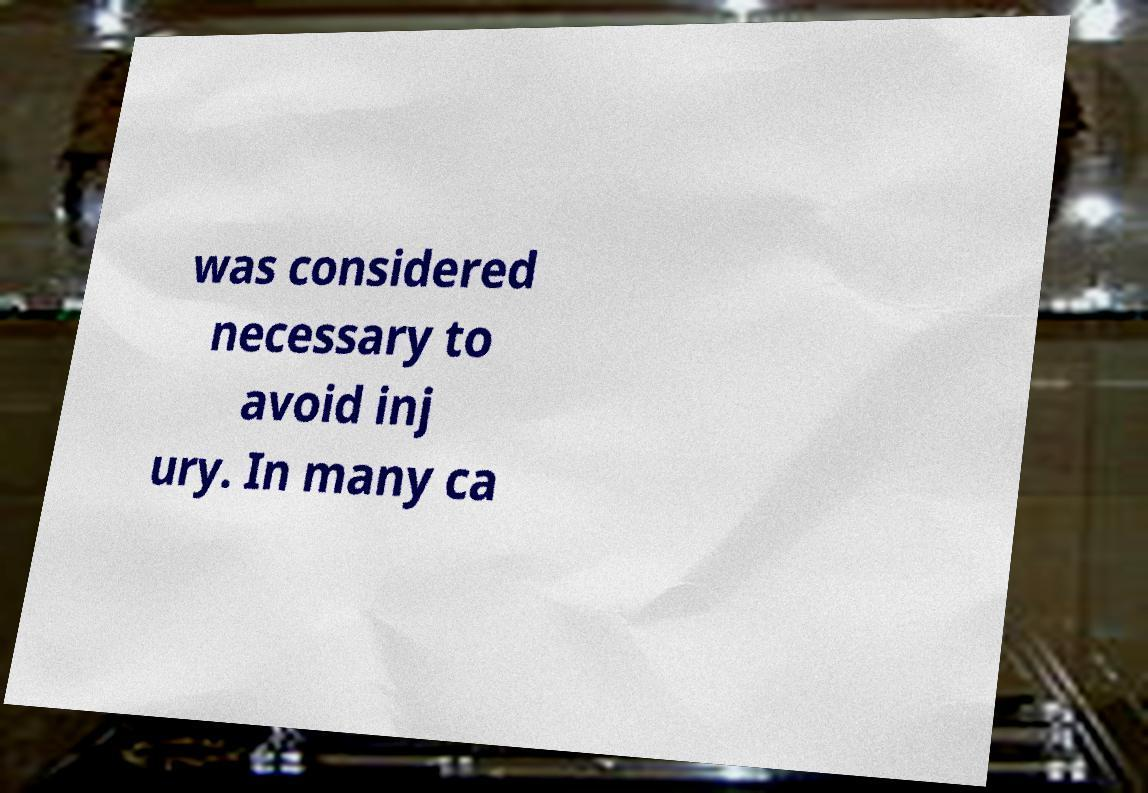For documentation purposes, I need the text within this image transcribed. Could you provide that? was considered necessary to avoid inj ury. In many ca 